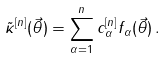<formula> <loc_0><loc_0><loc_500><loc_500>\tilde { \kappa } ^ { [ n ] } ( \vec { \theta } ) = \sum _ { \alpha = 1 } ^ { n } c _ { \alpha } ^ { [ n ] } f _ { \alpha } ( \vec { \theta } ) \, .</formula> 